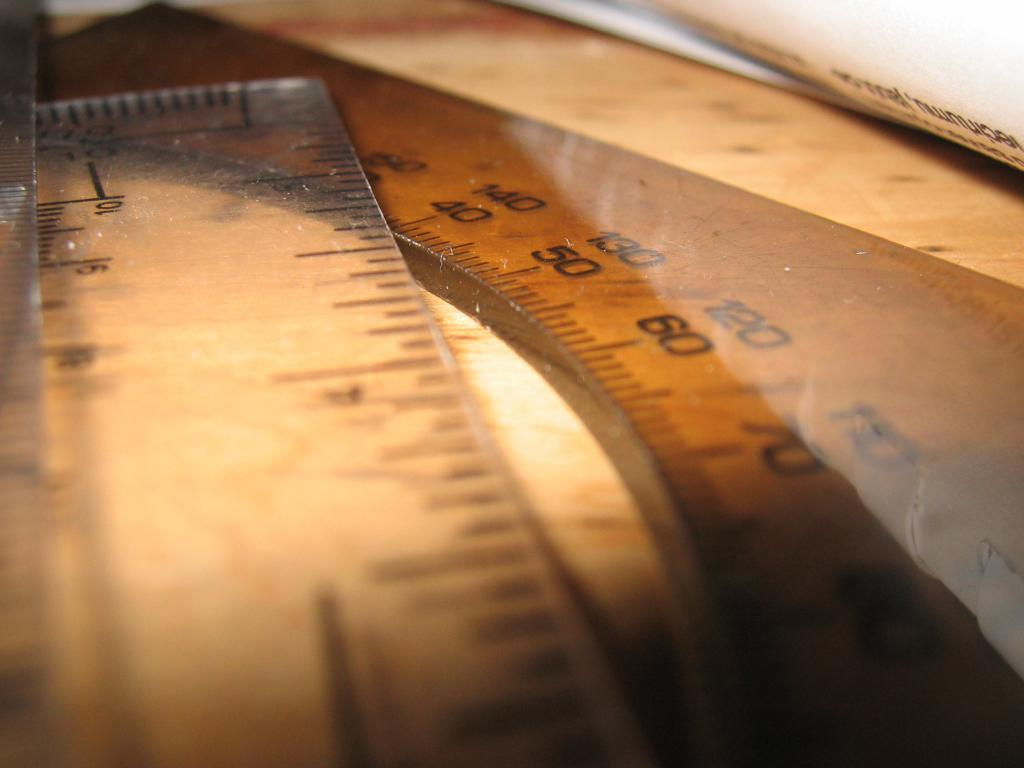<image>
Create a compact narrative representing the image presented. A ruler with the numbers 10 and  9 is laying with other measuring instruments. 